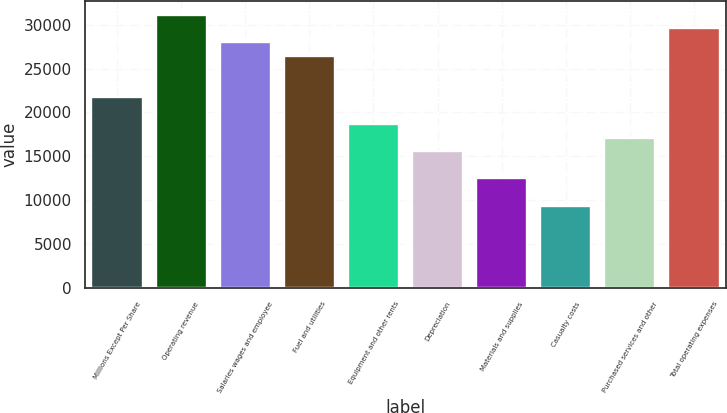Convert chart to OTSL. <chart><loc_0><loc_0><loc_500><loc_500><bar_chart><fcel>Millions Except Per Share<fcel>Operating revenue<fcel>Salaries wages and employee<fcel>Fuel and utilities<fcel>Equipment and other rents<fcel>Depreciation<fcel>Materials and supplies<fcel>Casualty costs<fcel>Purchased services and other<fcel>Total operating expenses<nl><fcel>21808.7<fcel>31154.8<fcel>28039.4<fcel>26481.8<fcel>18693.4<fcel>15578<fcel>12462.6<fcel>9347.28<fcel>17135.7<fcel>29597.1<nl></chart> 